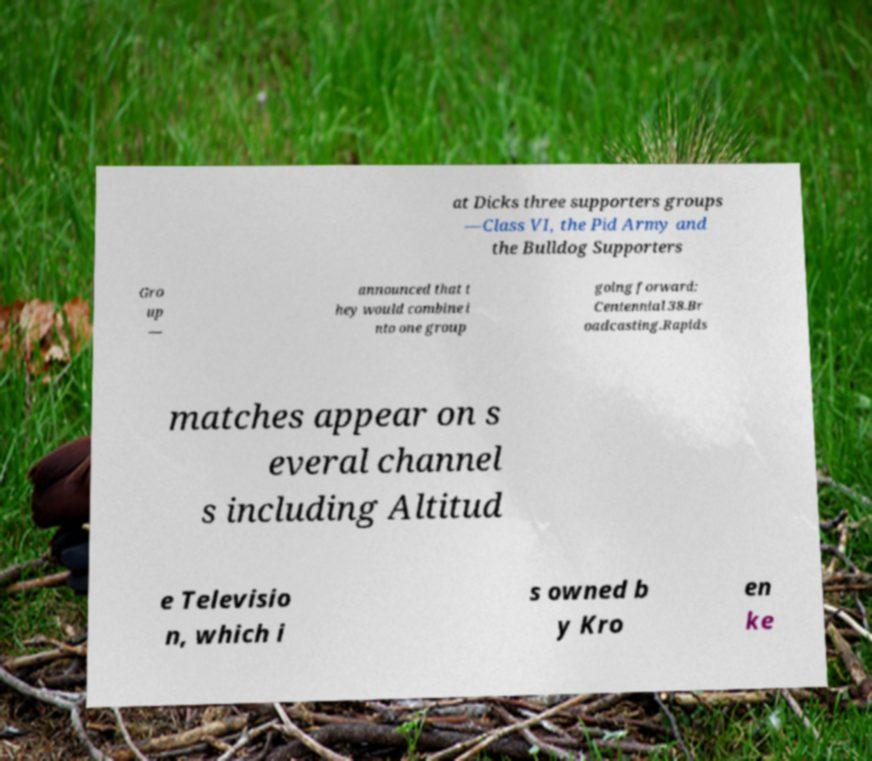What messages or text are displayed in this image? I need them in a readable, typed format. at Dicks three supporters groups —Class VI, the Pid Army and the Bulldog Supporters Gro up — announced that t hey would combine i nto one group going forward: Centennial 38.Br oadcasting.Rapids matches appear on s everal channel s including Altitud e Televisio n, which i s owned b y Kro en ke 